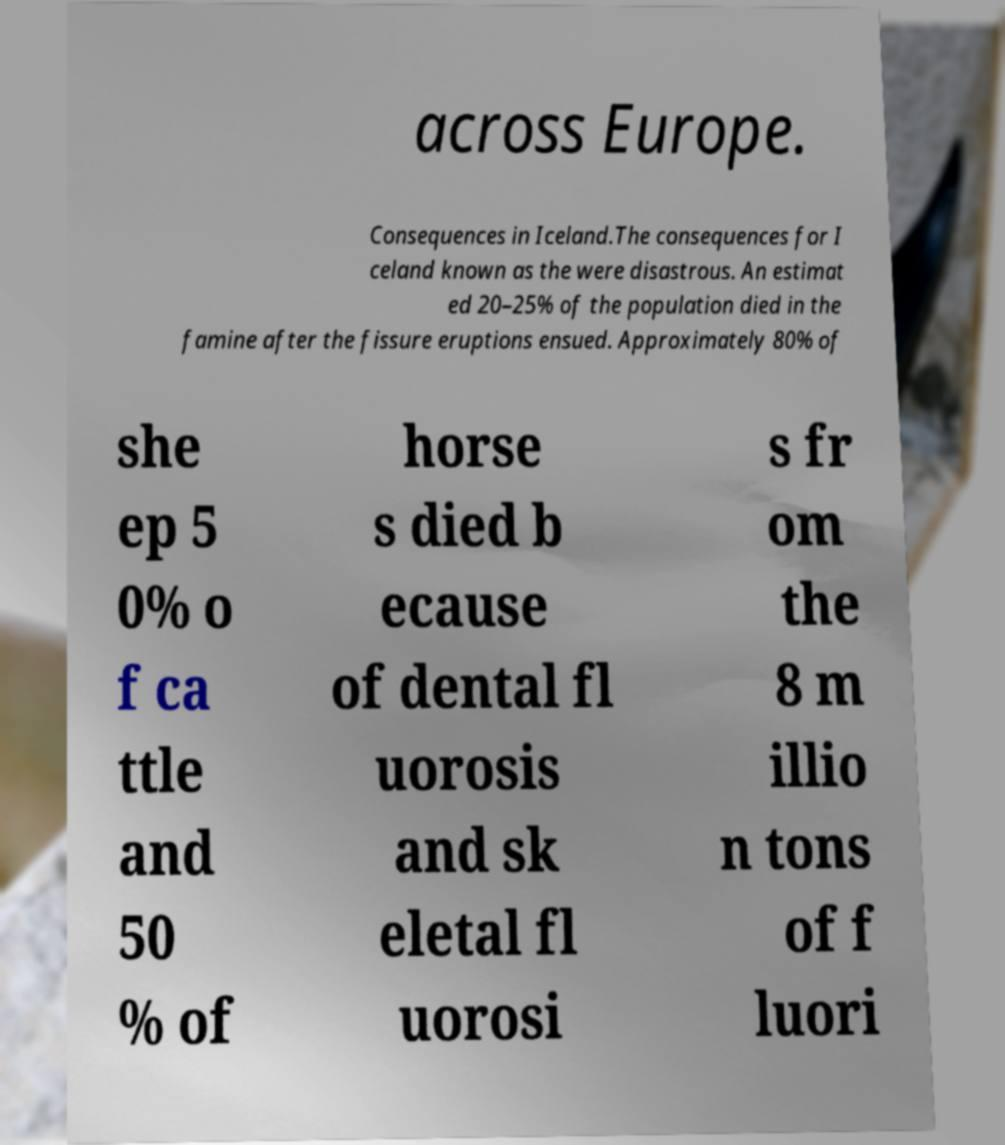Please identify and transcribe the text found in this image. across Europe. Consequences in Iceland.The consequences for I celand known as the were disastrous. An estimat ed 20–25% of the population died in the famine after the fissure eruptions ensued. Approximately 80% of she ep 5 0% o f ca ttle and 50 % of horse s died b ecause of dental fl uorosis and sk eletal fl uorosi s fr om the 8 m illio n tons of f luori 